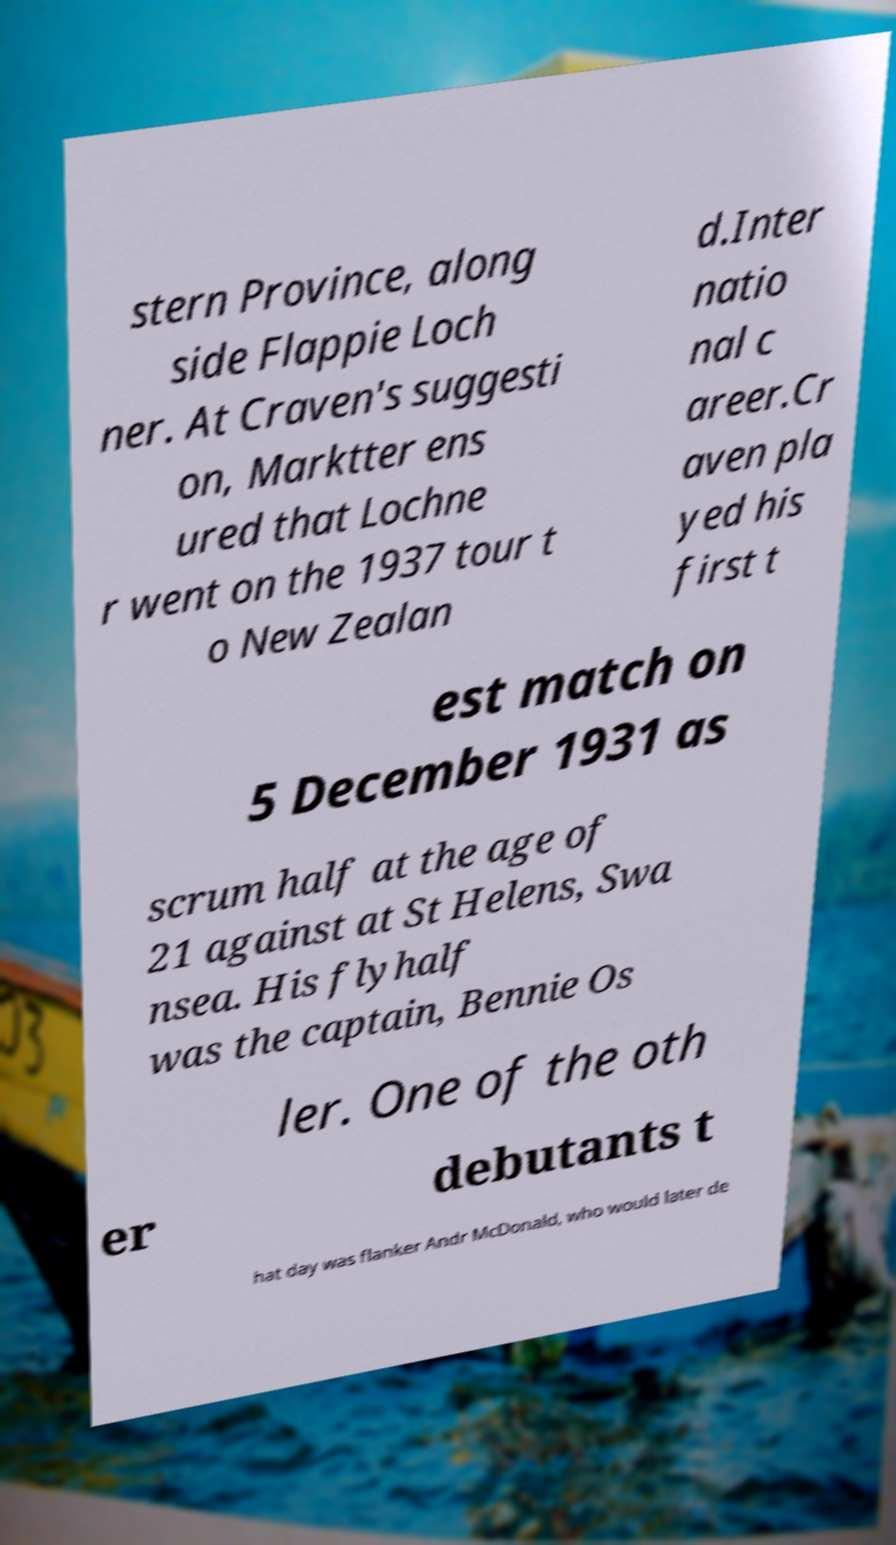Please read and relay the text visible in this image. What does it say? stern Province, along side Flappie Loch ner. At Craven's suggesti on, Marktter ens ured that Lochne r went on the 1937 tour t o New Zealan d.Inter natio nal c areer.Cr aven pla yed his first t est match on 5 December 1931 as scrum half at the age of 21 against at St Helens, Swa nsea. His flyhalf was the captain, Bennie Os ler. One of the oth er debutants t hat day was flanker Andr McDonald, who would later de 